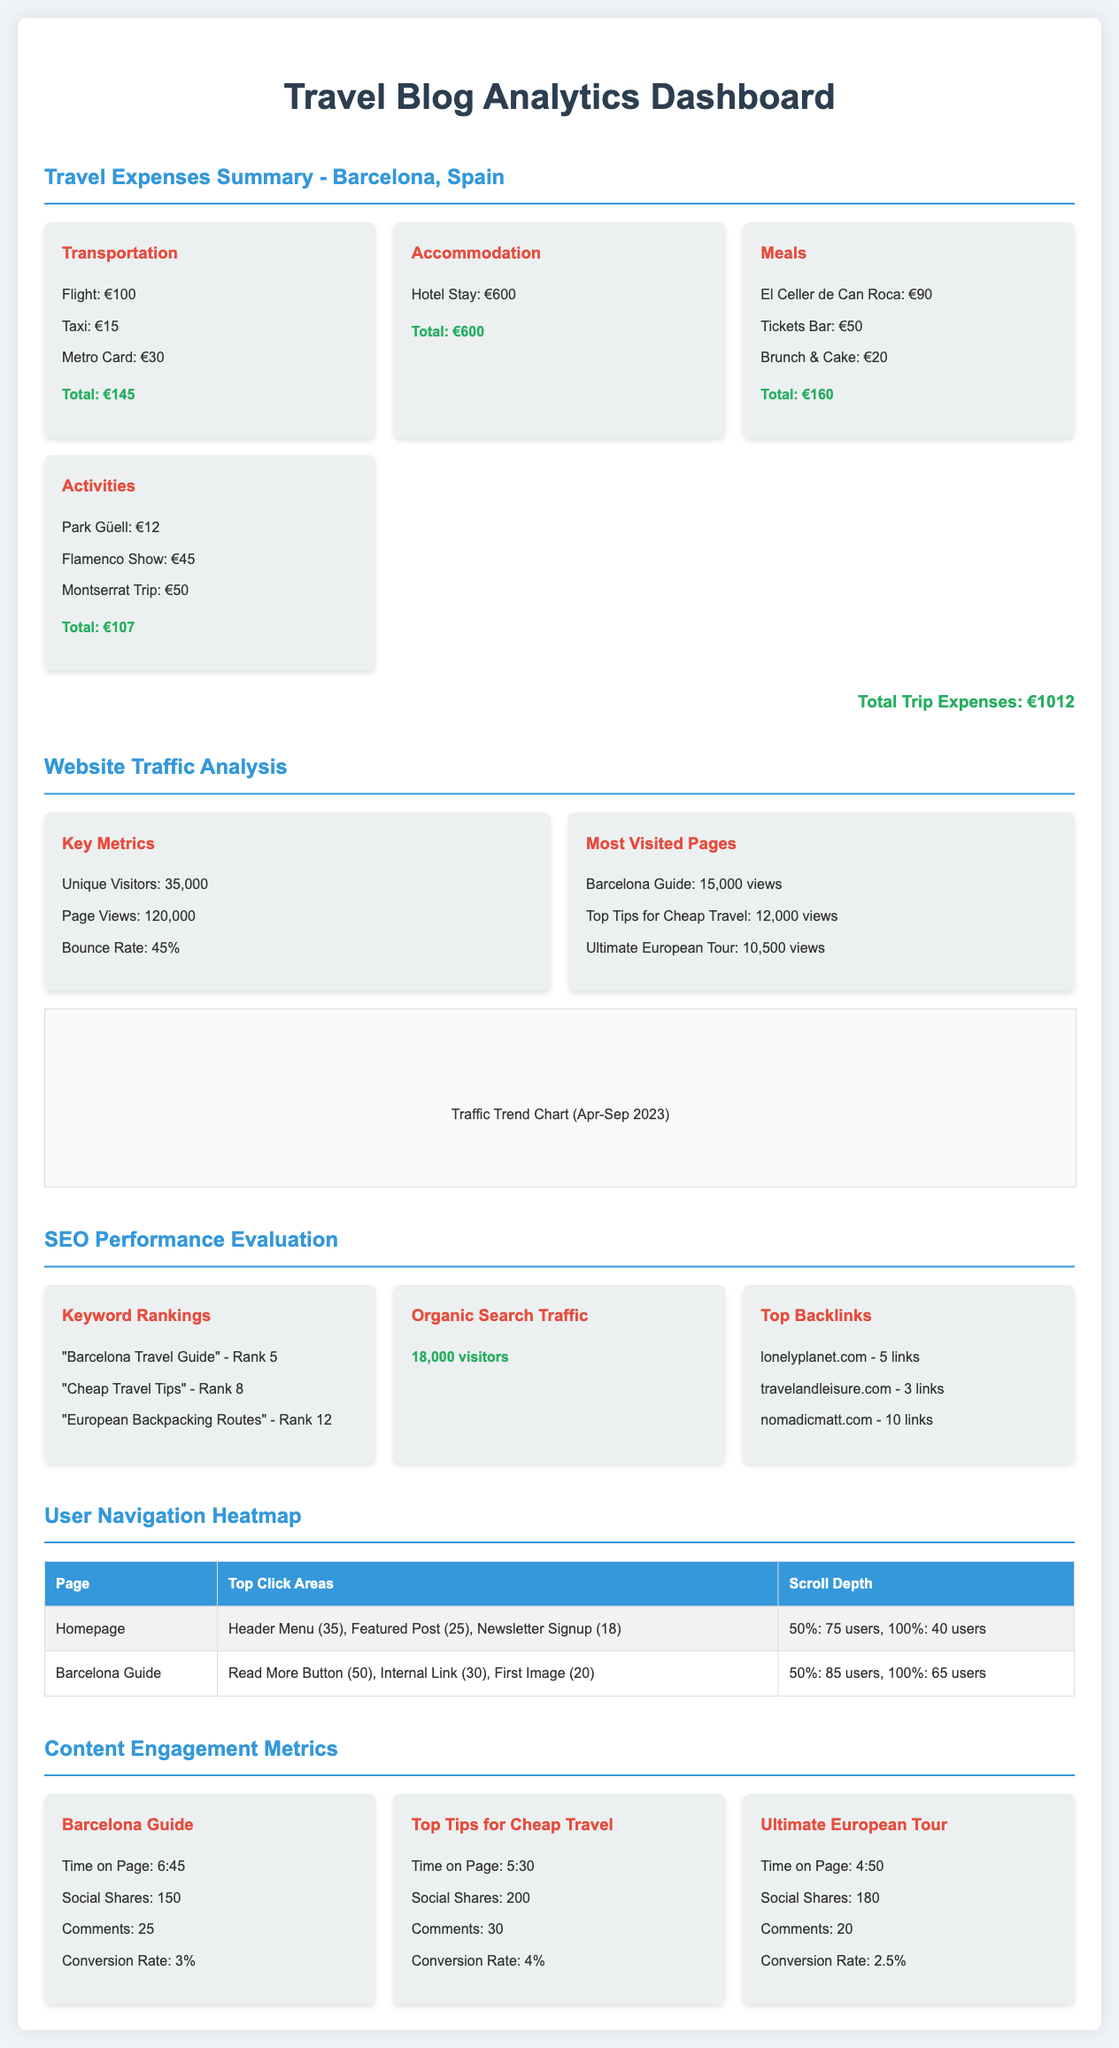What is the total travel expense for the trip? The total travel expense is clearly listed at the end of the travel expenses summary section.
Answer: €1012 How many unique visitors did the travel blog have? The number of unique visitors is provided in the website traffic analysis section.
Answer: 35,000 What rank does "Cheap Travel Tips" hold? The ranking for "Cheap Travel Tips" is indicated in the SEO performance evaluation section.
Answer: Rank 8 What is the total time spent on the "Barcelona Guide" page? The time spent on the "Barcelona Guide" page is provided under content engagement metrics.
Answer: 6:45 Which activity had the highest expense? The description of travel-related expenses lists the individual expenses for activities, helping identify the highest.
Answer: Flamenco Show: €45 What percentage is listed as the bounce rate? The bounce rate is part of the key metrics in the website traffic analysis section.
Answer: 45% How many comments did the "Top Tips for Cheap Travel" post receive? The engagement metrics for this post include the number of comments received.
Answer: 30 What are the top two most visited pages? The most visited pages are listed in the website traffic analysis, specifying their view counts.
Answer: Barcelona Guide, Top Tips for Cheap Travel What is the total amount spent on meals? The total amount spent is totaled in the meals expense section of the travel expenses summary.
Answer: €160 